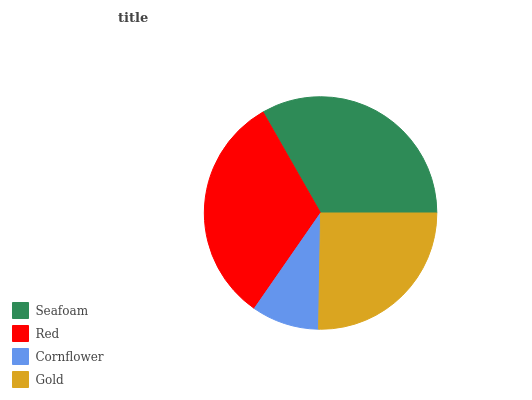Is Cornflower the minimum?
Answer yes or no. Yes. Is Seafoam the maximum?
Answer yes or no. Yes. Is Red the minimum?
Answer yes or no. No. Is Red the maximum?
Answer yes or no. No. Is Seafoam greater than Red?
Answer yes or no. Yes. Is Red less than Seafoam?
Answer yes or no. Yes. Is Red greater than Seafoam?
Answer yes or no. No. Is Seafoam less than Red?
Answer yes or no. No. Is Red the high median?
Answer yes or no. Yes. Is Gold the low median?
Answer yes or no. Yes. Is Cornflower the high median?
Answer yes or no. No. Is Seafoam the low median?
Answer yes or no. No. 